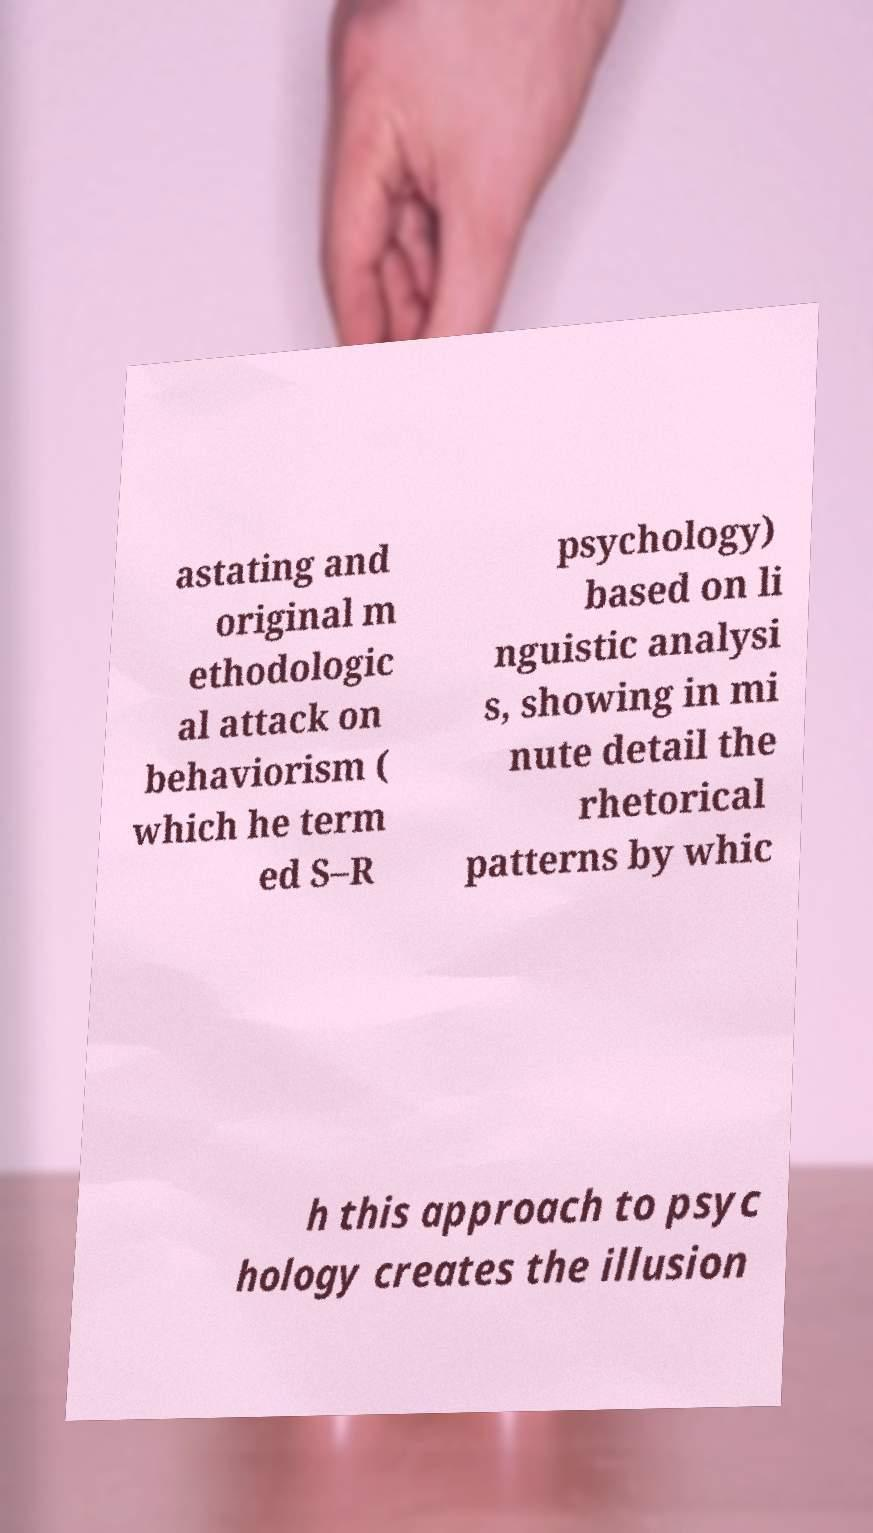Can you accurately transcribe the text from the provided image for me? astating and original m ethodologic al attack on behaviorism ( which he term ed S–R psychology) based on li nguistic analysi s, showing in mi nute detail the rhetorical patterns by whic h this approach to psyc hology creates the illusion 